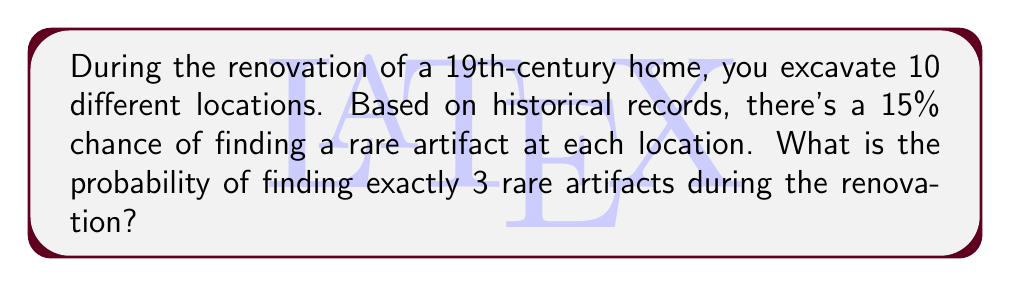Help me with this question. To solve this problem, we can use the binomial probability distribution:

1. Identify the parameters:
   - $n = 10$ (number of excavation locations)
   - $p = 0.15$ (probability of finding a rare artifact at each location)
   - $k = 3$ (number of successes we're interested in)

2. Use the binomial probability formula:

   $$P(X = k) = \binom{n}{k} p^k (1-p)^{n-k}$$

   Where $\binom{n}{k}$ is the binomial coefficient.

3. Calculate the binomial coefficient:
   
   $$\binom{10}{3} = \frac{10!}{3!(10-3)!} = \frac{10!}{3!7!} = 120$$

4. Substitute the values into the formula:

   $$P(X = 3) = 120 \cdot (0.15)^3 \cdot (1-0.15)^{10-3}$$
   
   $$= 120 \cdot (0.15)^3 \cdot (0.85)^7$$

5. Calculate the result:
   
   $$= 120 \cdot 0.003375 \cdot 0.3164671$$
   
   $$= 0.1281$$

Therefore, the probability of finding exactly 3 rare artifacts during the renovation is approximately 0.1281 or 12.81%.
Answer: 0.1281 